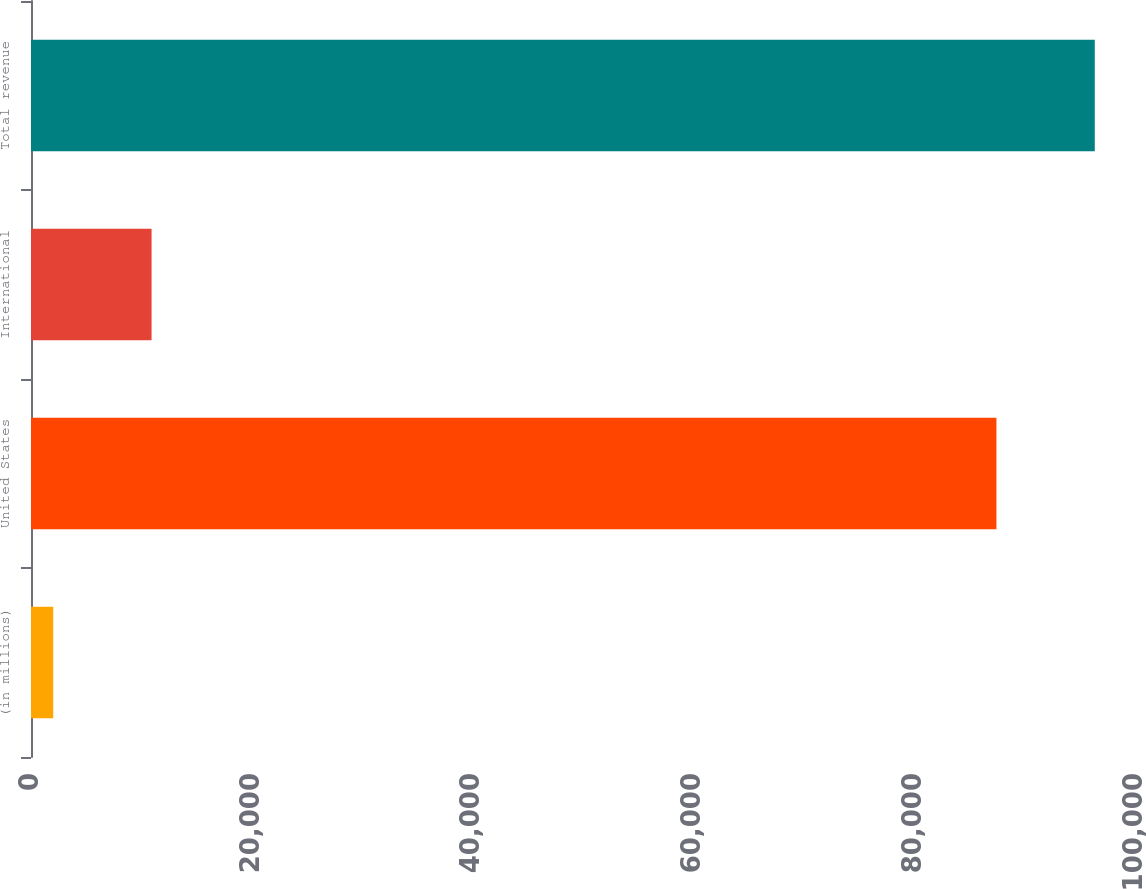Convert chart to OTSL. <chart><loc_0><loc_0><loc_500><loc_500><bar_chart><fcel>(in millions)<fcel>United States<fcel>International<fcel>Total revenue<nl><fcel>2014<fcel>87449<fcel>10921<fcel>96356<nl></chart> 